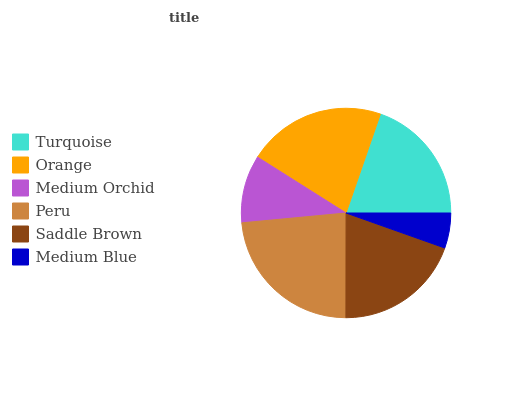Is Medium Blue the minimum?
Answer yes or no. Yes. Is Peru the maximum?
Answer yes or no. Yes. Is Orange the minimum?
Answer yes or no. No. Is Orange the maximum?
Answer yes or no. No. Is Orange greater than Turquoise?
Answer yes or no. Yes. Is Turquoise less than Orange?
Answer yes or no. Yes. Is Turquoise greater than Orange?
Answer yes or no. No. Is Orange less than Turquoise?
Answer yes or no. No. Is Turquoise the high median?
Answer yes or no. Yes. Is Saddle Brown the low median?
Answer yes or no. Yes. Is Medium Blue the high median?
Answer yes or no. No. Is Peru the low median?
Answer yes or no. No. 